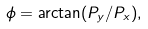<formula> <loc_0><loc_0><loc_500><loc_500>\phi = \arctan ( P _ { y } / P _ { x } ) ,</formula> 